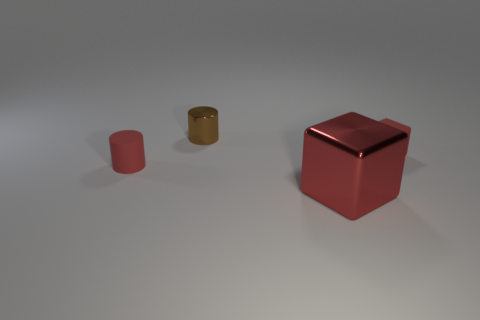There is a object that is on the left side of the big red cube and in front of the red matte cube; what is its size?
Make the answer very short. Small. What number of cubes are the same size as the red cylinder?
Keep it short and to the point. 1. How many red cylinders are in front of the block that is behind the large object?
Offer a terse response. 1. There is a small matte object left of the big red thing; is it the same color as the shiny block?
Offer a terse response. Yes. Is there a big red cube that is behind the tiny metallic cylinder that is behind the small thing on the right side of the big shiny block?
Your response must be concise. No. The red object that is both left of the tiny red rubber cube and behind the large shiny object has what shape?
Keep it short and to the point. Cylinder. Are there any metallic cylinders of the same color as the big shiny cube?
Your answer should be very brief. No. There is a cube behind the small cylinder that is on the left side of the shiny cylinder; what color is it?
Ensure brevity in your answer.  Red. There is a matte thing that is left of the cube behind the matte cylinder that is on the left side of the small brown cylinder; what size is it?
Your answer should be very brief. Small. Is the brown cylinder made of the same material as the thing on the left side of the small brown thing?
Provide a short and direct response. No. 